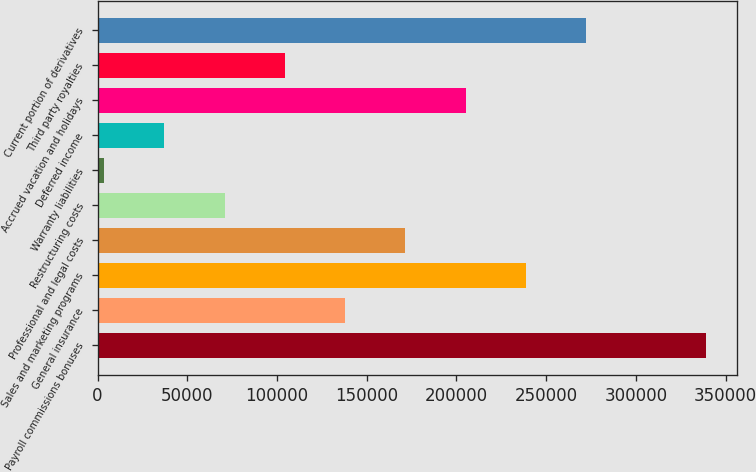<chart> <loc_0><loc_0><loc_500><loc_500><bar_chart><fcel>Payroll commissions bonuses<fcel>General insurance<fcel>Sales and marketing programs<fcel>Professional and legal costs<fcel>Restructuring costs<fcel>Warranty liabilities<fcel>Deferred income<fcel>Accrued vacation and holidays<fcel>Third party royalties<fcel>Current portion of derivatives<nl><fcel>339308<fcel>137888<fcel>238598<fcel>171458<fcel>70748<fcel>3608<fcel>37178<fcel>205028<fcel>104318<fcel>272168<nl></chart> 